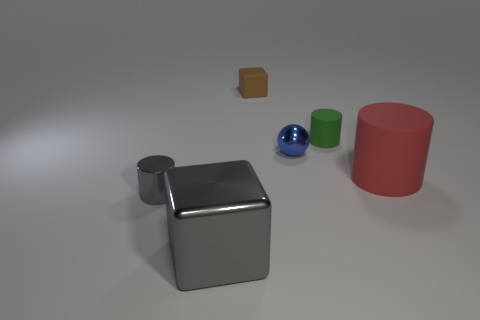How many objects are there in total? There are five objects in total, consisting of a large gray metal cube, a smaller brown cube, a green cylinder, a blue sphere, and a red cylinder. 